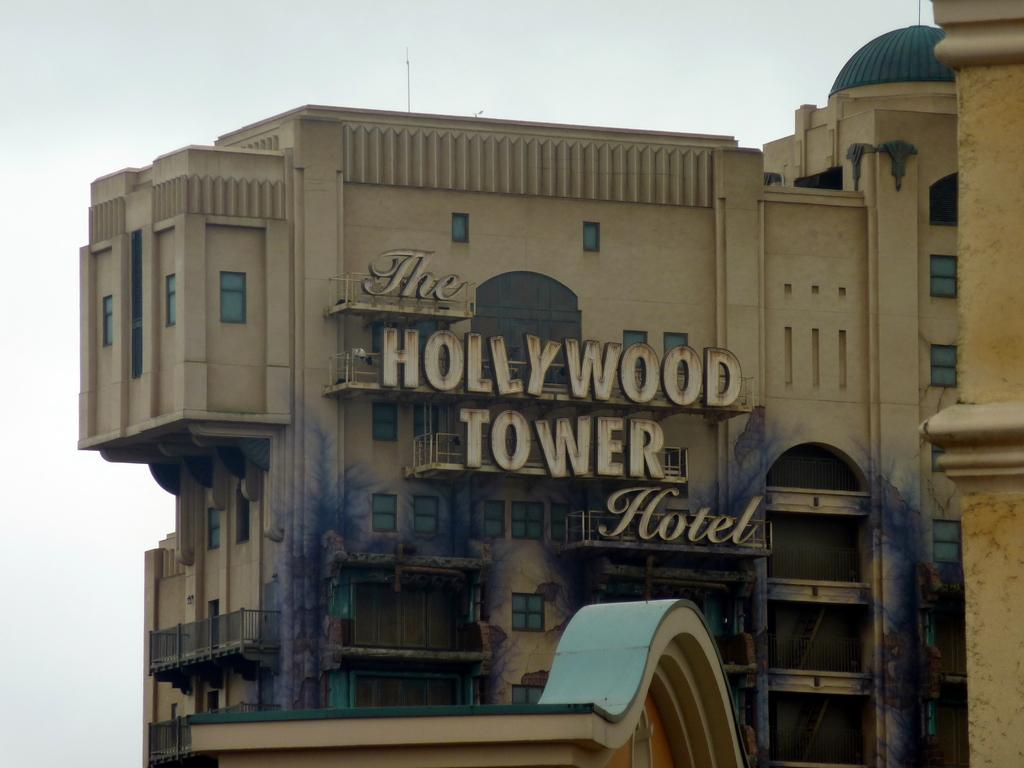What is the main subject in the center of the image? There is a building in the center of the image. What can be seen at the top of the image? The sky is visible at the top of the image. How many giants are holding the building in the image? There are no giants present in the image, so it is not possible to answer that question. 